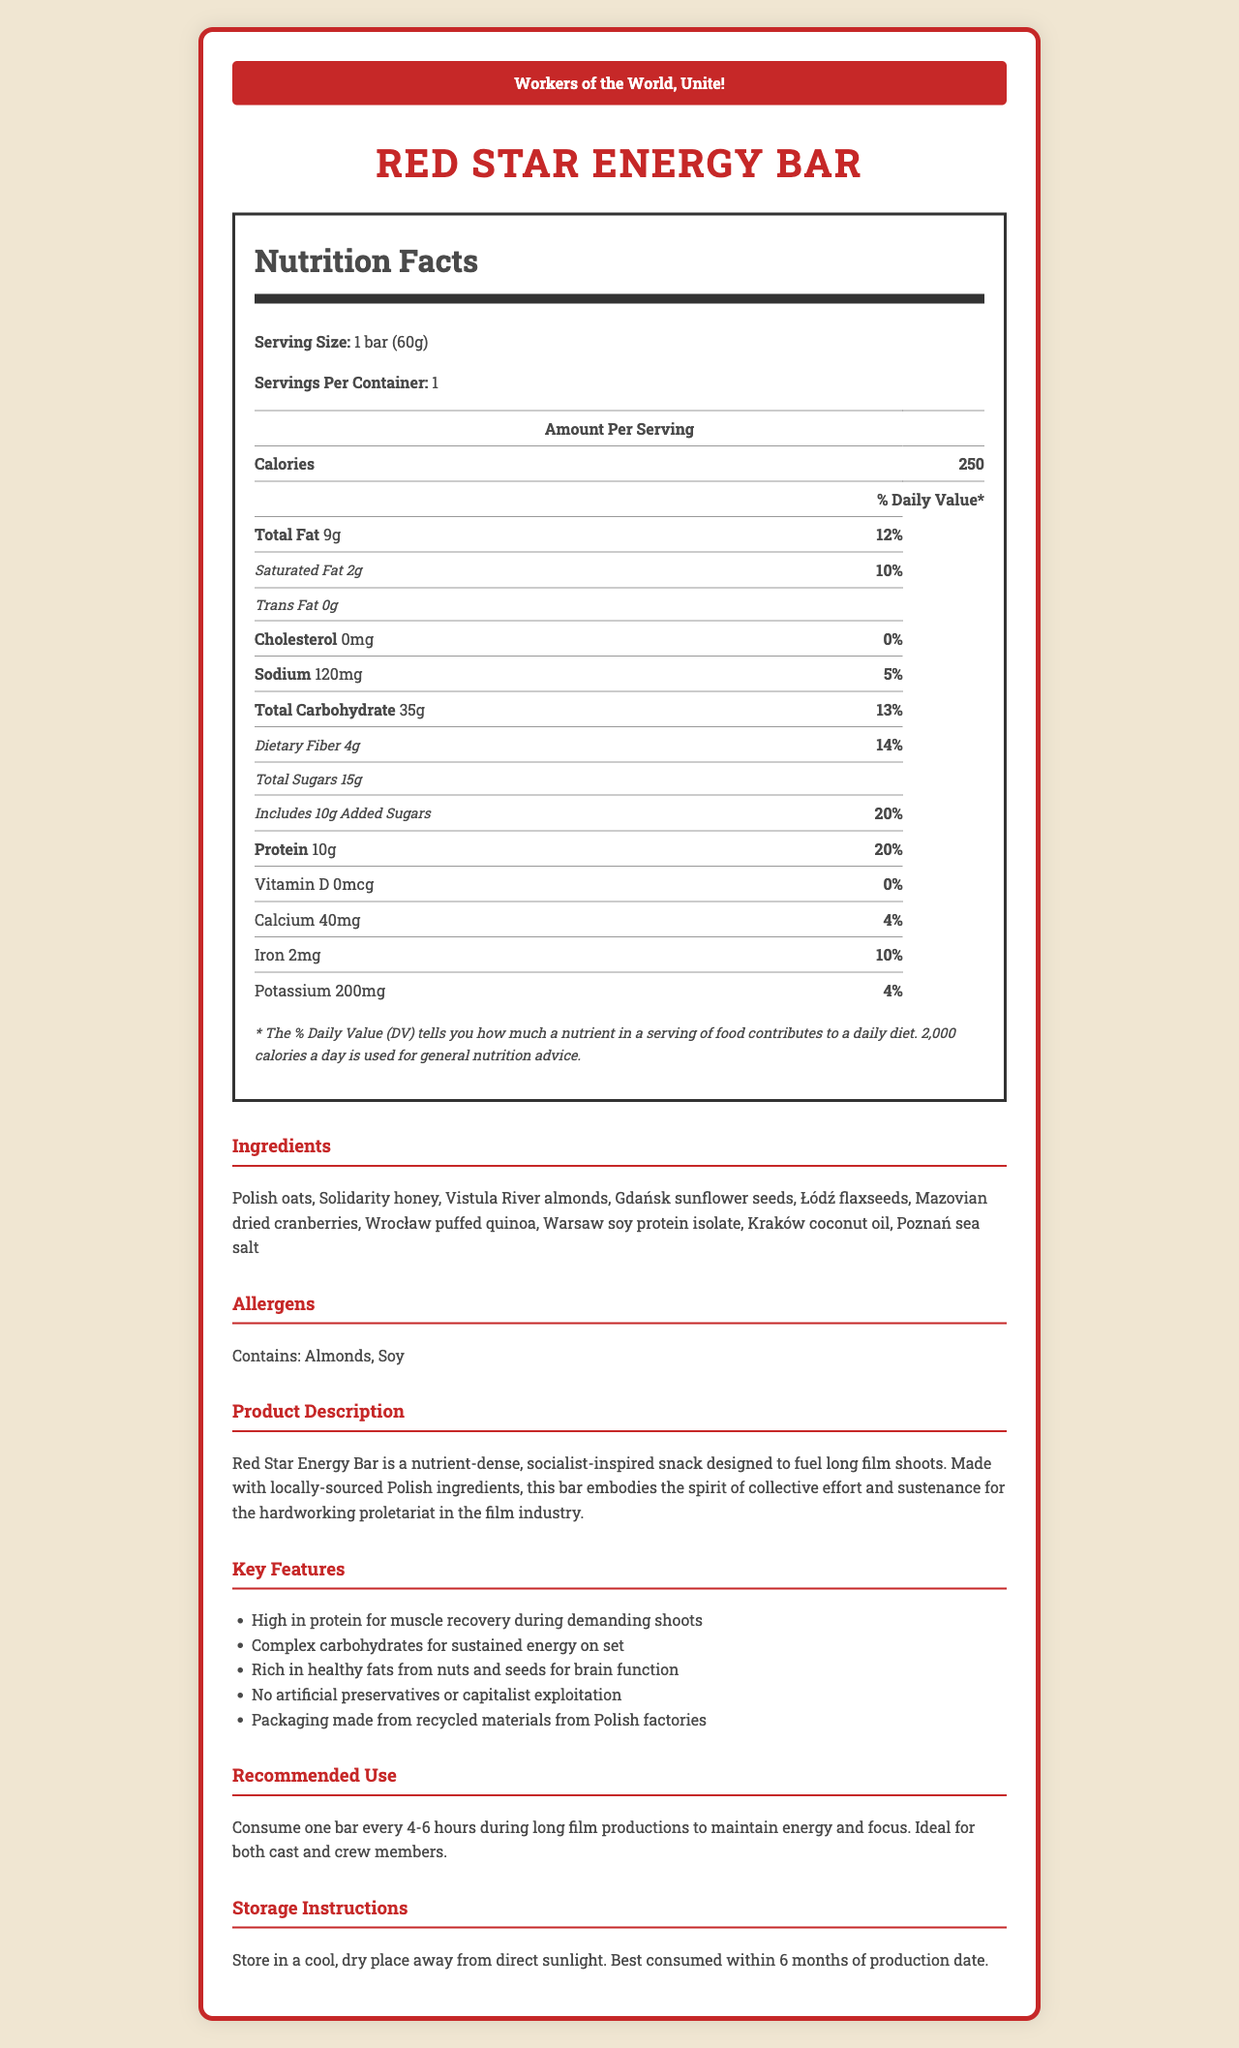What is the serving size of the Red Star Energy Bar? The serving size is explicitly stated in the document under the Nutrition Facts heading.
Answer: 1 bar (60g) How many calories are in one serving of the Red Star Energy Bar? The document shows the calorie count right under the amount per serving section in the Nutrition Facts.
Answer: 250 What percentage of the daily value of dietary fiber does one Red Star Energy Bar provide? This information is listed next to the dietary fiber content under the Total Carbohydrate section.
Answer: 14% Which of the following ingredients is NOT a part of the Red Star Energy Bar? A. Polish oats B. Italian almonds C. Gdańsk sunflower seeds D. Warsaw soy protein isolate The list of ingredients includes Polish oats, Gdańsk sunflower seeds, and Warsaw soy protein isolate, but not Italian almonds.
Answer: B What is the daily value percentage of sodium in one serving of the Red Star Energy Bar? The sodium daily value percentage is listed next to the sodium amount in the Nutrition Facts.
Answer: 5% Does the Red Star Energy Bar contain any cholesterol? The document shows that cholesterol amounts to 0mg with a daily value percentage of 0%.
Answer: No Which feature of the Red Star Energy Bar reflects its socialist theme? A. High in protein for muscle recovery B. Complex carbohydrates for sustained energy C. No artificial preservatives or capitalist exploitation D. Packaging made from recycled materials The feature "No artificial preservatives or capitalist exploitation" clearly aligns with the socialist theme described in the document.
Answer: C What allergens are present in the Red Star Energy Bar? The allergens section lists these two allergens as part of the bar's content.
Answer: Almonds, Soy Is the Red Star Energy Bar recommended for consumption during short or long film productions? The recommended use section explicitly mentions it is ideal for long film productions to maintain energy and focus.
Answer: Long film productions Summarize the primary theme and nutritional benefits of the Red Star Energy Bar. The document provides a detailed description of the product’s theme, nutritional benefits, ingredients, and key features, all aligning with a socialist value system and intended for energy maintenance during extended film shoots.
Answer: The Red Star Energy Bar is a socialist-themed snack designed for long film shoots, emphasizing collective effort using locally-sourced Polish ingredients. It offers high protein for muscle recovery, complex carbohydrates for sustained energy, and healthy fats for brain function. It is free from artificial preservatives and promotes environmental consciousness with recycled packaging. What is the exact amount of Iron in one serving of the Red Star Energy Bar? This information is found in the Nutrition Facts section under the Iron listing.
Answer: 2 mg For what timeframe is the Red Star Energy Bar best consumed after production? The storage instructions section recommends consuming the bar within 6 months of production.
Answer: Within 6 months Is it possible to determine the cost of the Red Star Energy Bar from the document? The document provides detailed nutritional information, ingredients, and usage recommendations but does not include any information regarding the cost of the energy bar.
Answer: Not enough information 